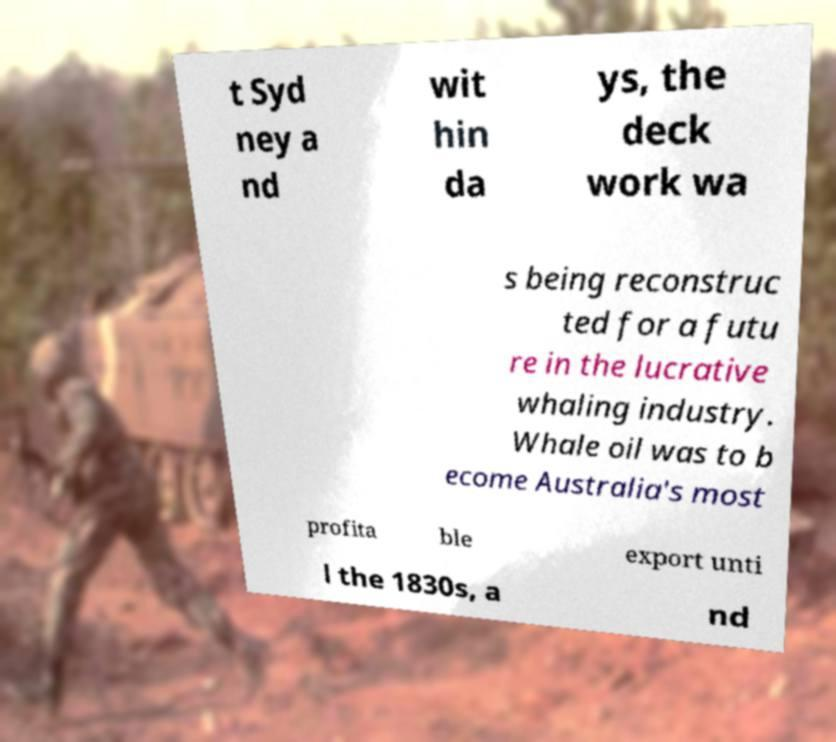Please identify and transcribe the text found in this image. t Syd ney a nd wit hin da ys, the deck work wa s being reconstruc ted for a futu re in the lucrative whaling industry. Whale oil was to b ecome Australia's most profita ble export unti l the 1830s, a nd 